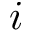<formula> <loc_0><loc_0><loc_500><loc_500>i</formula> 